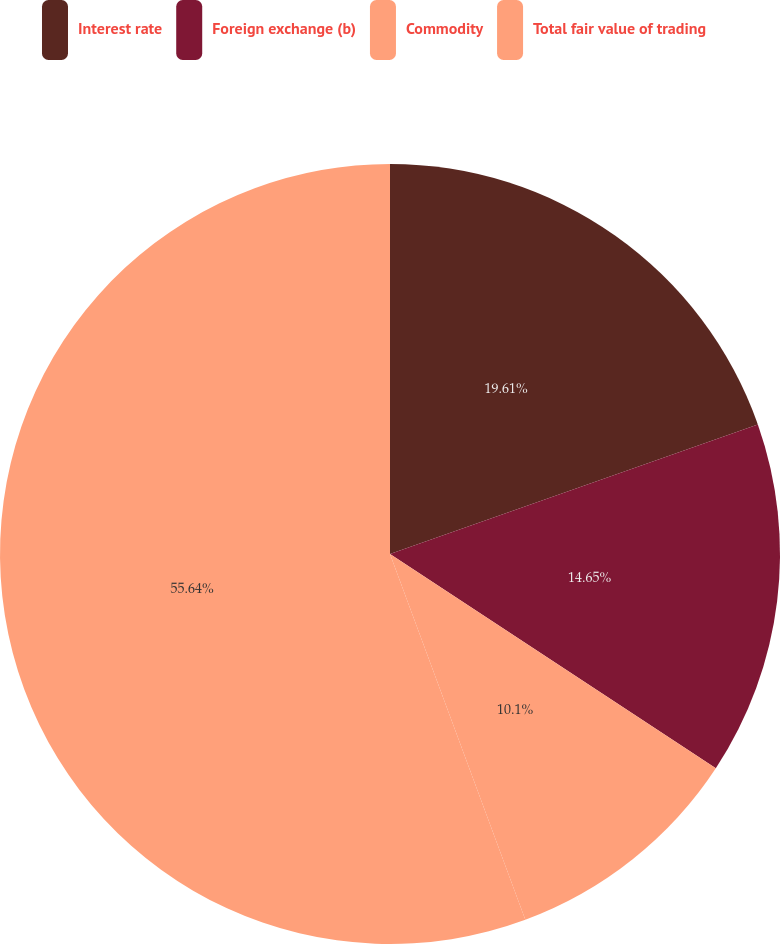<chart> <loc_0><loc_0><loc_500><loc_500><pie_chart><fcel>Interest rate<fcel>Foreign exchange (b)<fcel>Commodity<fcel>Total fair value of trading<nl><fcel>19.61%<fcel>14.65%<fcel>10.1%<fcel>55.64%<nl></chart> 